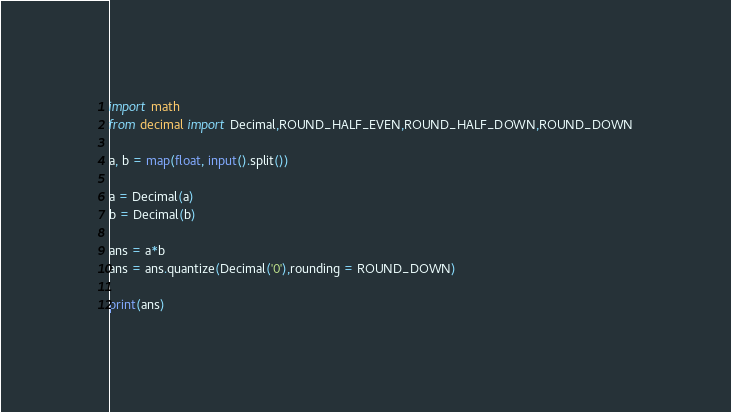Convert code to text. <code><loc_0><loc_0><loc_500><loc_500><_Python_>import math
from decimal import Decimal,ROUND_HALF_EVEN,ROUND_HALF_DOWN,ROUND_DOWN

a, b = map(float, input().split())

a = Decimal(a)
b = Decimal(b)

ans = a*b
ans = ans.quantize(Decimal('0'),rounding = ROUND_DOWN)

print(ans)</code> 